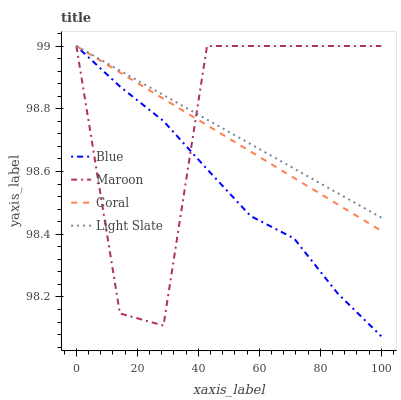Does Blue have the minimum area under the curve?
Answer yes or no. Yes. Does Maroon have the maximum area under the curve?
Answer yes or no. Yes. Does Light Slate have the minimum area under the curve?
Answer yes or no. No. Does Light Slate have the maximum area under the curve?
Answer yes or no. No. Is Coral the smoothest?
Answer yes or no. Yes. Is Maroon the roughest?
Answer yes or no. Yes. Is Light Slate the smoothest?
Answer yes or no. No. Is Light Slate the roughest?
Answer yes or no. No. Does Blue have the lowest value?
Answer yes or no. Yes. Does Coral have the lowest value?
Answer yes or no. No. Does Maroon have the highest value?
Answer yes or no. Yes. Does Light Slate intersect Maroon?
Answer yes or no. Yes. Is Light Slate less than Maroon?
Answer yes or no. No. Is Light Slate greater than Maroon?
Answer yes or no. No. 